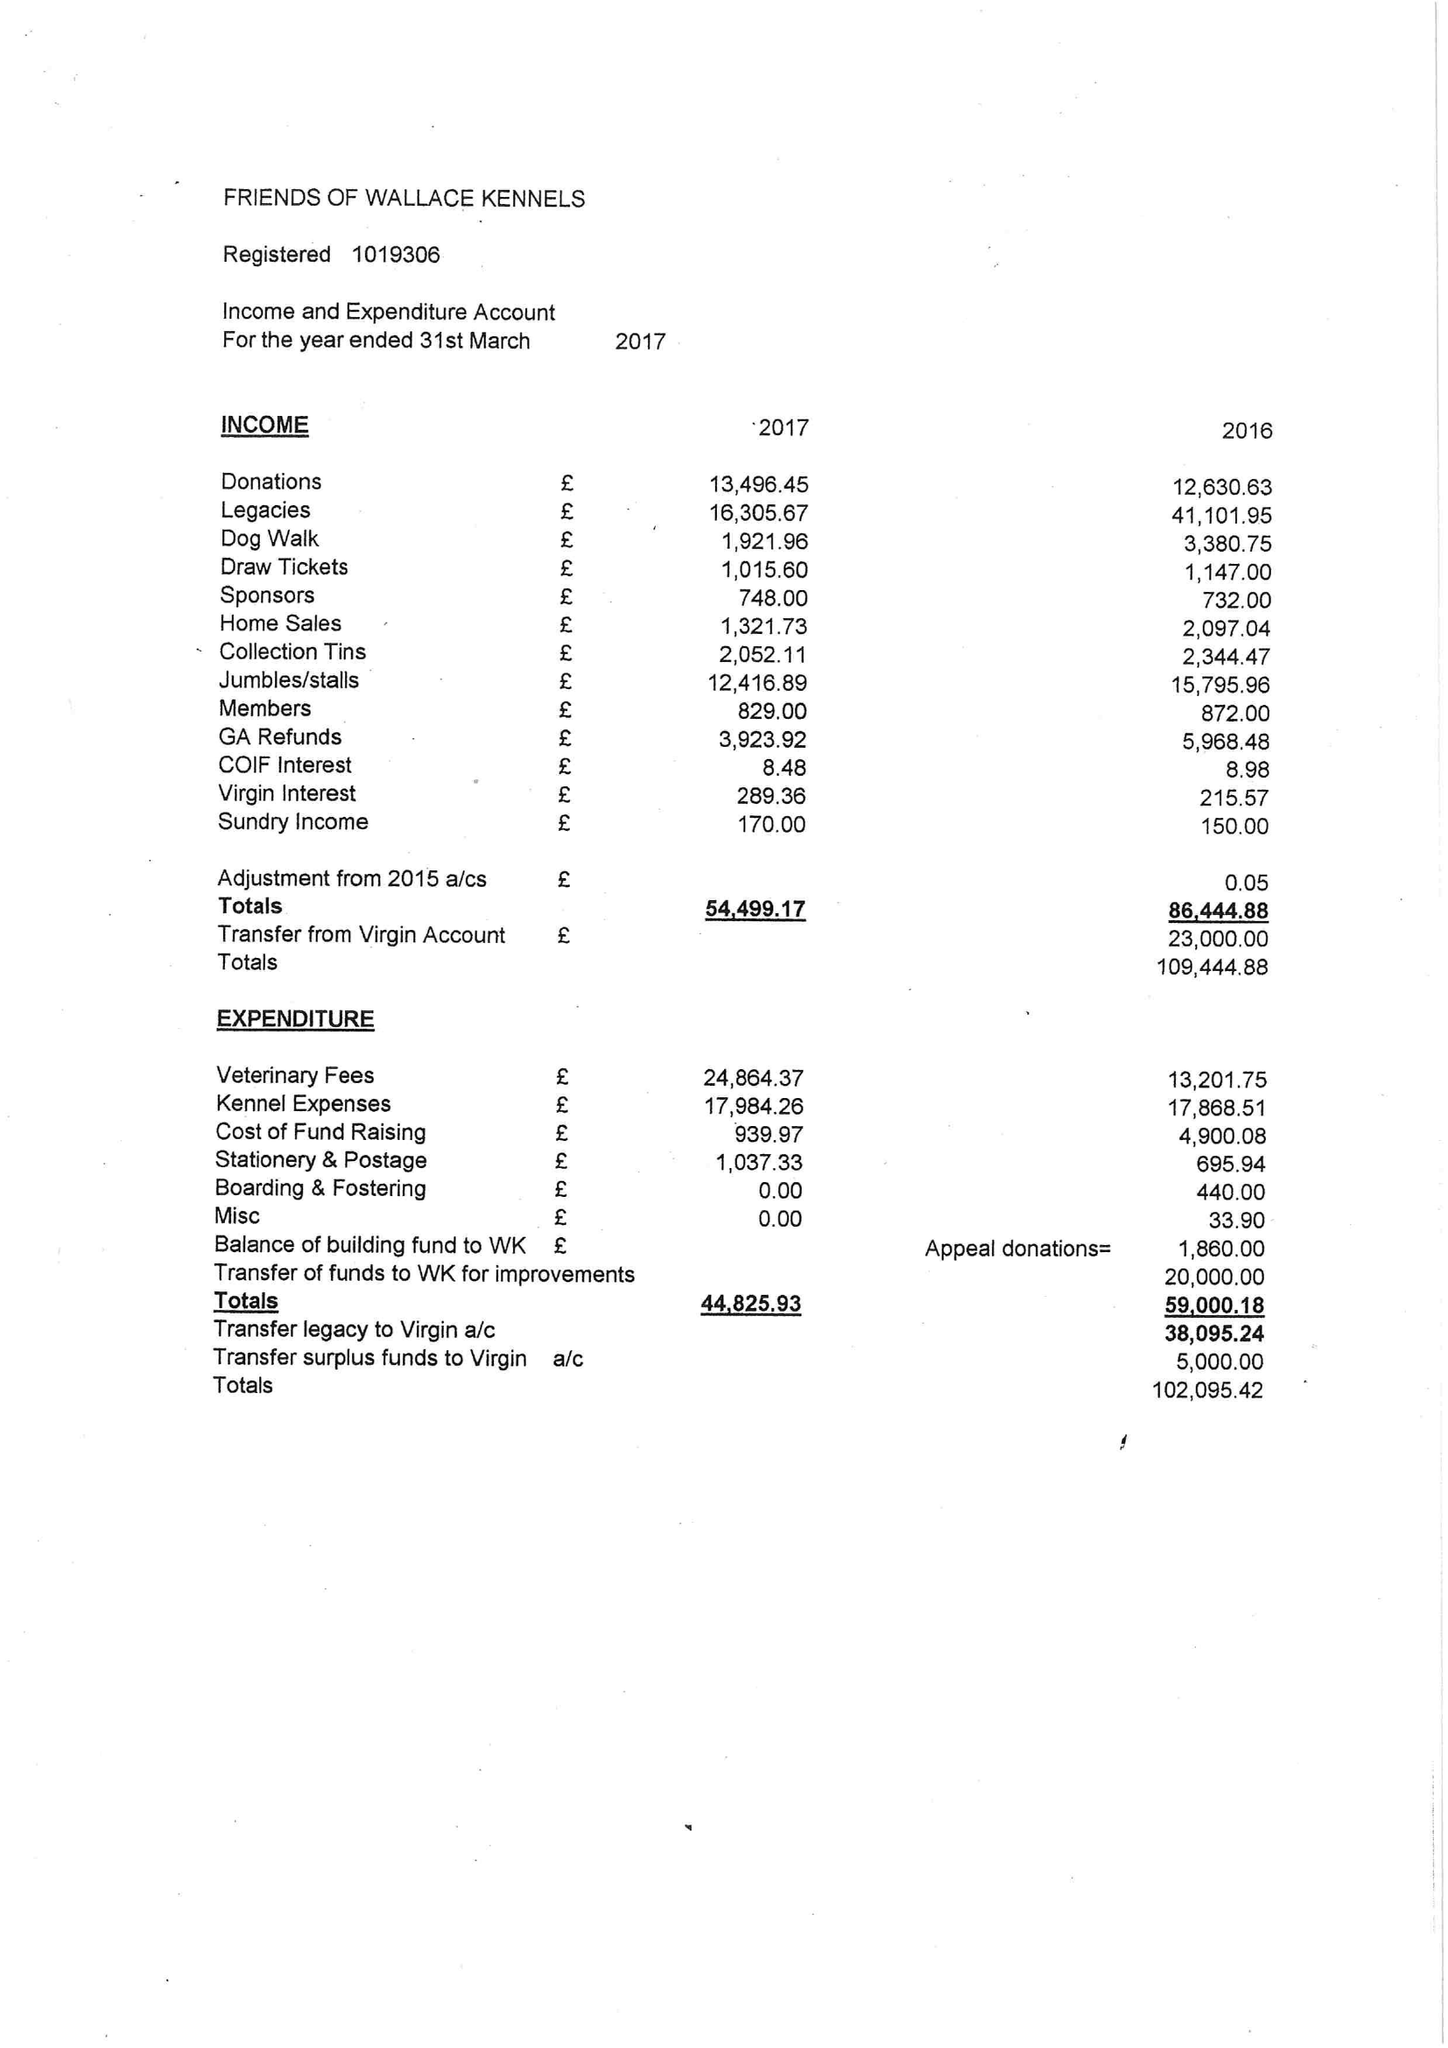What is the value for the charity_number?
Answer the question using a single word or phrase. 1019306 